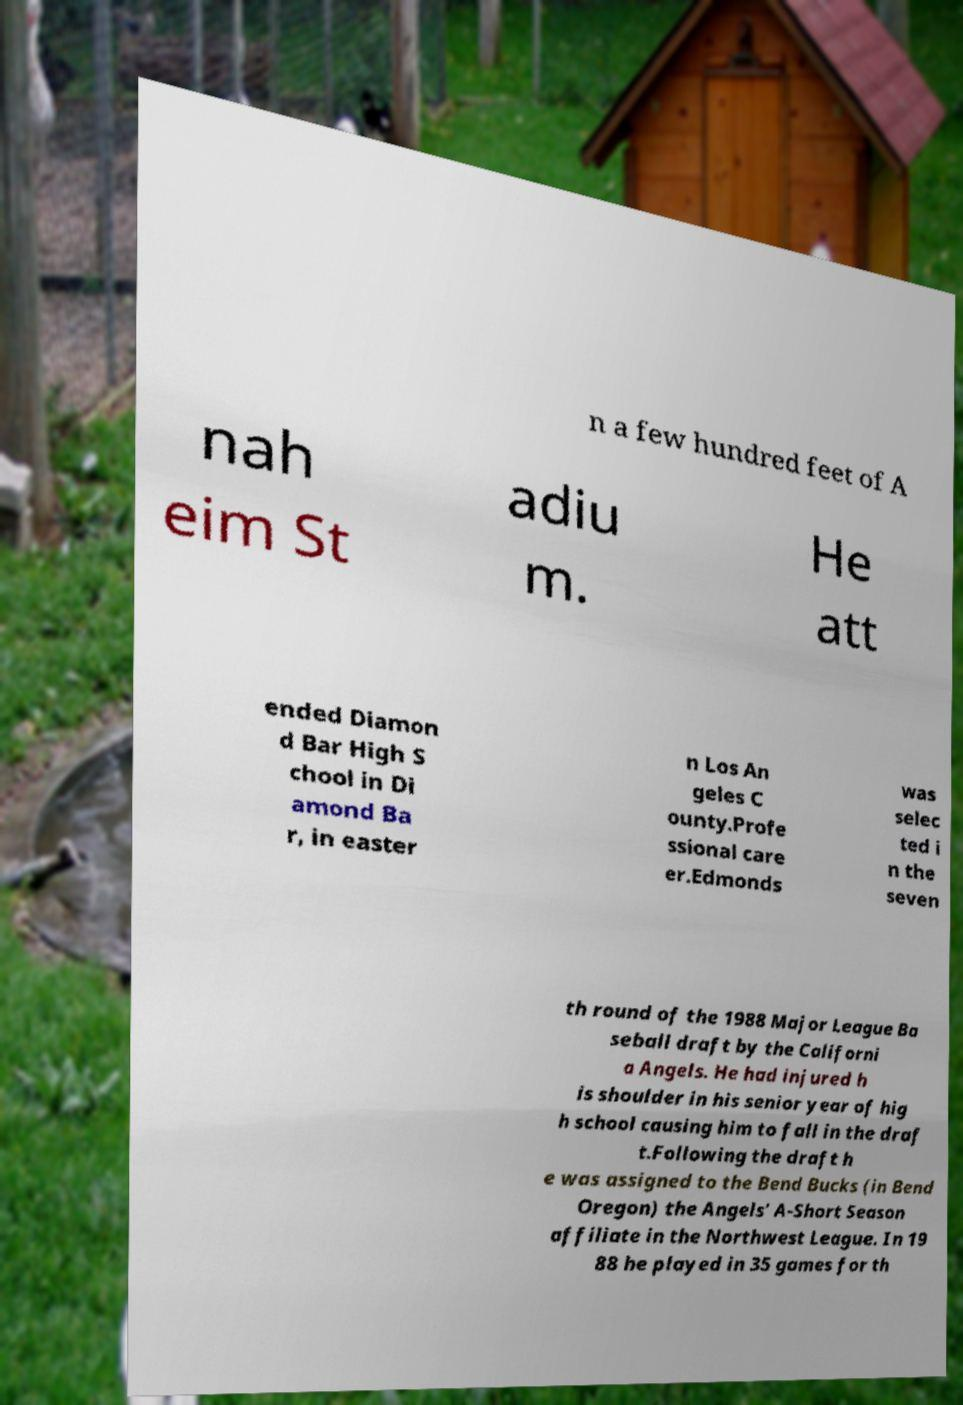For documentation purposes, I need the text within this image transcribed. Could you provide that? n a few hundred feet of A nah eim St adiu m. He att ended Diamon d Bar High S chool in Di amond Ba r, in easter n Los An geles C ounty.Profe ssional care er.Edmonds was selec ted i n the seven th round of the 1988 Major League Ba seball draft by the Californi a Angels. He had injured h is shoulder in his senior year of hig h school causing him to fall in the draf t.Following the draft h e was assigned to the Bend Bucks (in Bend Oregon) the Angels' A-Short Season affiliate in the Northwest League. In 19 88 he played in 35 games for th 